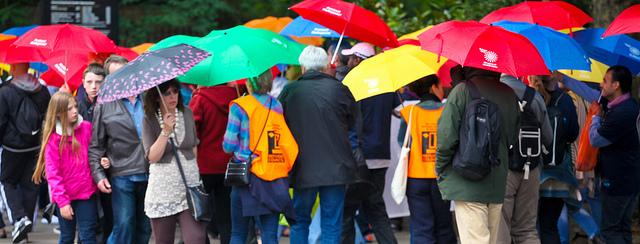What are the people holding?
Give a very brief answer. Umbrellas. Is it a sunny day?
Be succinct. No. Is this an umbrella exhibition?
Quick response, please. No. 